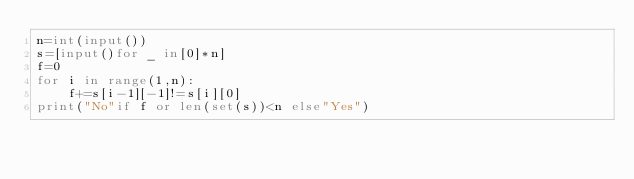Convert code to text. <code><loc_0><loc_0><loc_500><loc_500><_Python_>n=int(input())
s=[input()for _ in[0]*n]
f=0
for i in range(1,n):
    f+=s[i-1][-1]!=s[i][0]
print("No"if f or len(set(s))<n else"Yes")
</code> 